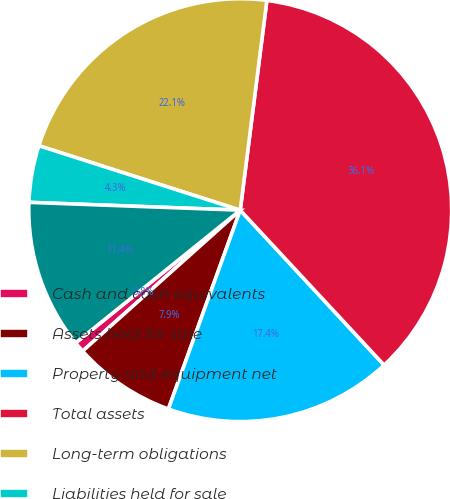Convert chart to OTSL. <chart><loc_0><loc_0><loc_500><loc_500><pie_chart><fcel>Cash and cash equivalents<fcel>Assets held for sale<fcel>Property and equipment net<fcel>Total assets<fcel>Long-term obligations<fcel>Liabilities held for sale<fcel>Total stockholders' equity<nl><fcel>0.81%<fcel>7.87%<fcel>17.43%<fcel>36.08%<fcel>22.08%<fcel>4.34%<fcel>11.39%<nl></chart> 